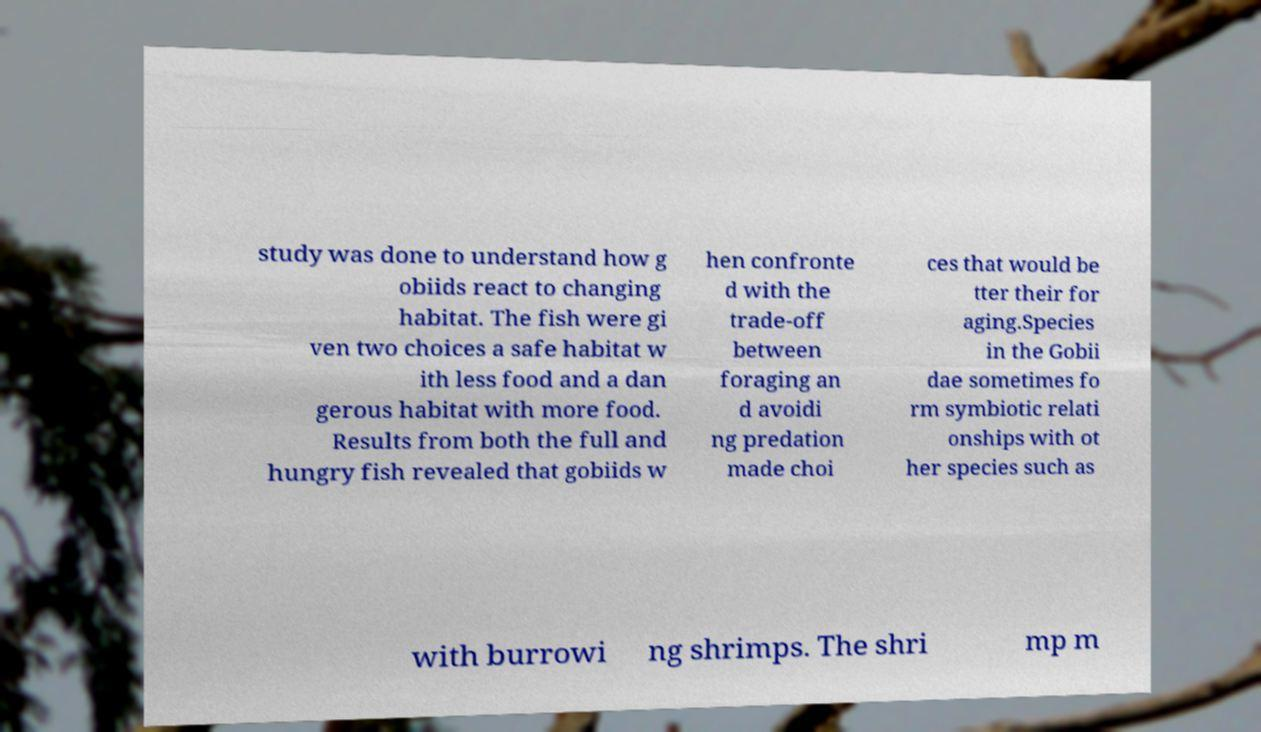Can you accurately transcribe the text from the provided image for me? study was done to understand how g obiids react to changing habitat. The fish were gi ven two choices a safe habitat w ith less food and a dan gerous habitat with more food. Results from both the full and hungry fish revealed that gobiids w hen confronte d with the trade-off between foraging an d avoidi ng predation made choi ces that would be tter their for aging.Species in the Gobii dae sometimes fo rm symbiotic relati onships with ot her species such as with burrowi ng shrimps. The shri mp m 